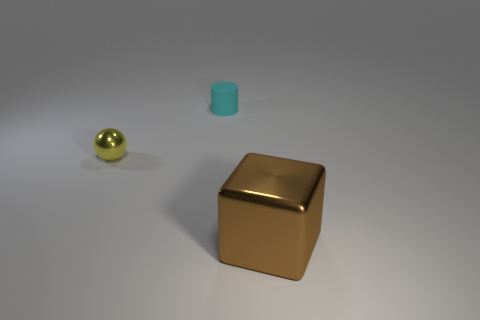Is there anything else that has the same size as the brown shiny object?
Offer a terse response. No. What is the material of the tiny thing on the right side of the yellow metal sphere?
Provide a succinct answer. Rubber. Are there fewer tiny cylinders that are on the left side of the tiny cyan cylinder than big purple spheres?
Your answer should be very brief. No. Is the shape of the cyan rubber object the same as the brown metallic object?
Offer a terse response. No. Is there any other thing that is the same shape as the small matte thing?
Your response must be concise. No. Are there any small blue cylinders?
Ensure brevity in your answer.  No. Does the yellow object have the same shape as the object on the right side of the tiny cyan matte object?
Your response must be concise. No. What material is the object in front of the tiny yellow shiny thing that is in front of the tiny cylinder?
Provide a succinct answer. Metal. What color is the rubber object?
Make the answer very short. Cyan. Are there any small rubber cylinders of the same color as the block?
Offer a terse response. No. 